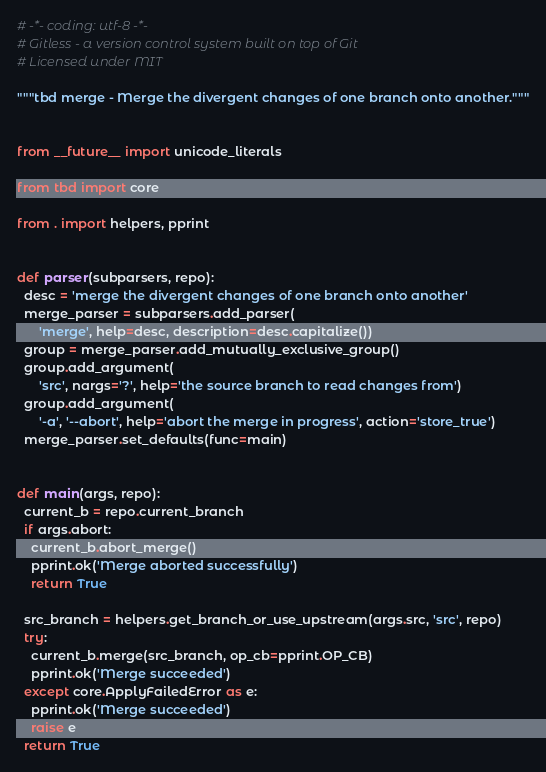Convert code to text. <code><loc_0><loc_0><loc_500><loc_500><_Python_># -*- coding: utf-8 -*-
# Gitless - a version control system built on top of Git
# Licensed under MIT

"""tbd merge - Merge the divergent changes of one branch onto another."""


from __future__ import unicode_literals

from tbd import core

from . import helpers, pprint


def parser(subparsers, repo):
  desc = 'merge the divergent changes of one branch onto another'
  merge_parser = subparsers.add_parser(
      'merge', help=desc, description=desc.capitalize())
  group = merge_parser.add_mutually_exclusive_group()
  group.add_argument(
      'src', nargs='?', help='the source branch to read changes from')
  group.add_argument(
      '-a', '--abort', help='abort the merge in progress', action='store_true')
  merge_parser.set_defaults(func=main)


def main(args, repo):
  current_b = repo.current_branch
  if args.abort:
    current_b.abort_merge()
    pprint.ok('Merge aborted successfully')
    return True

  src_branch = helpers.get_branch_or_use_upstream(args.src, 'src', repo)
  try:
    current_b.merge(src_branch, op_cb=pprint.OP_CB)
    pprint.ok('Merge succeeded')
  except core.ApplyFailedError as e:
    pprint.ok('Merge succeeded')
    raise e
  return True
</code> 